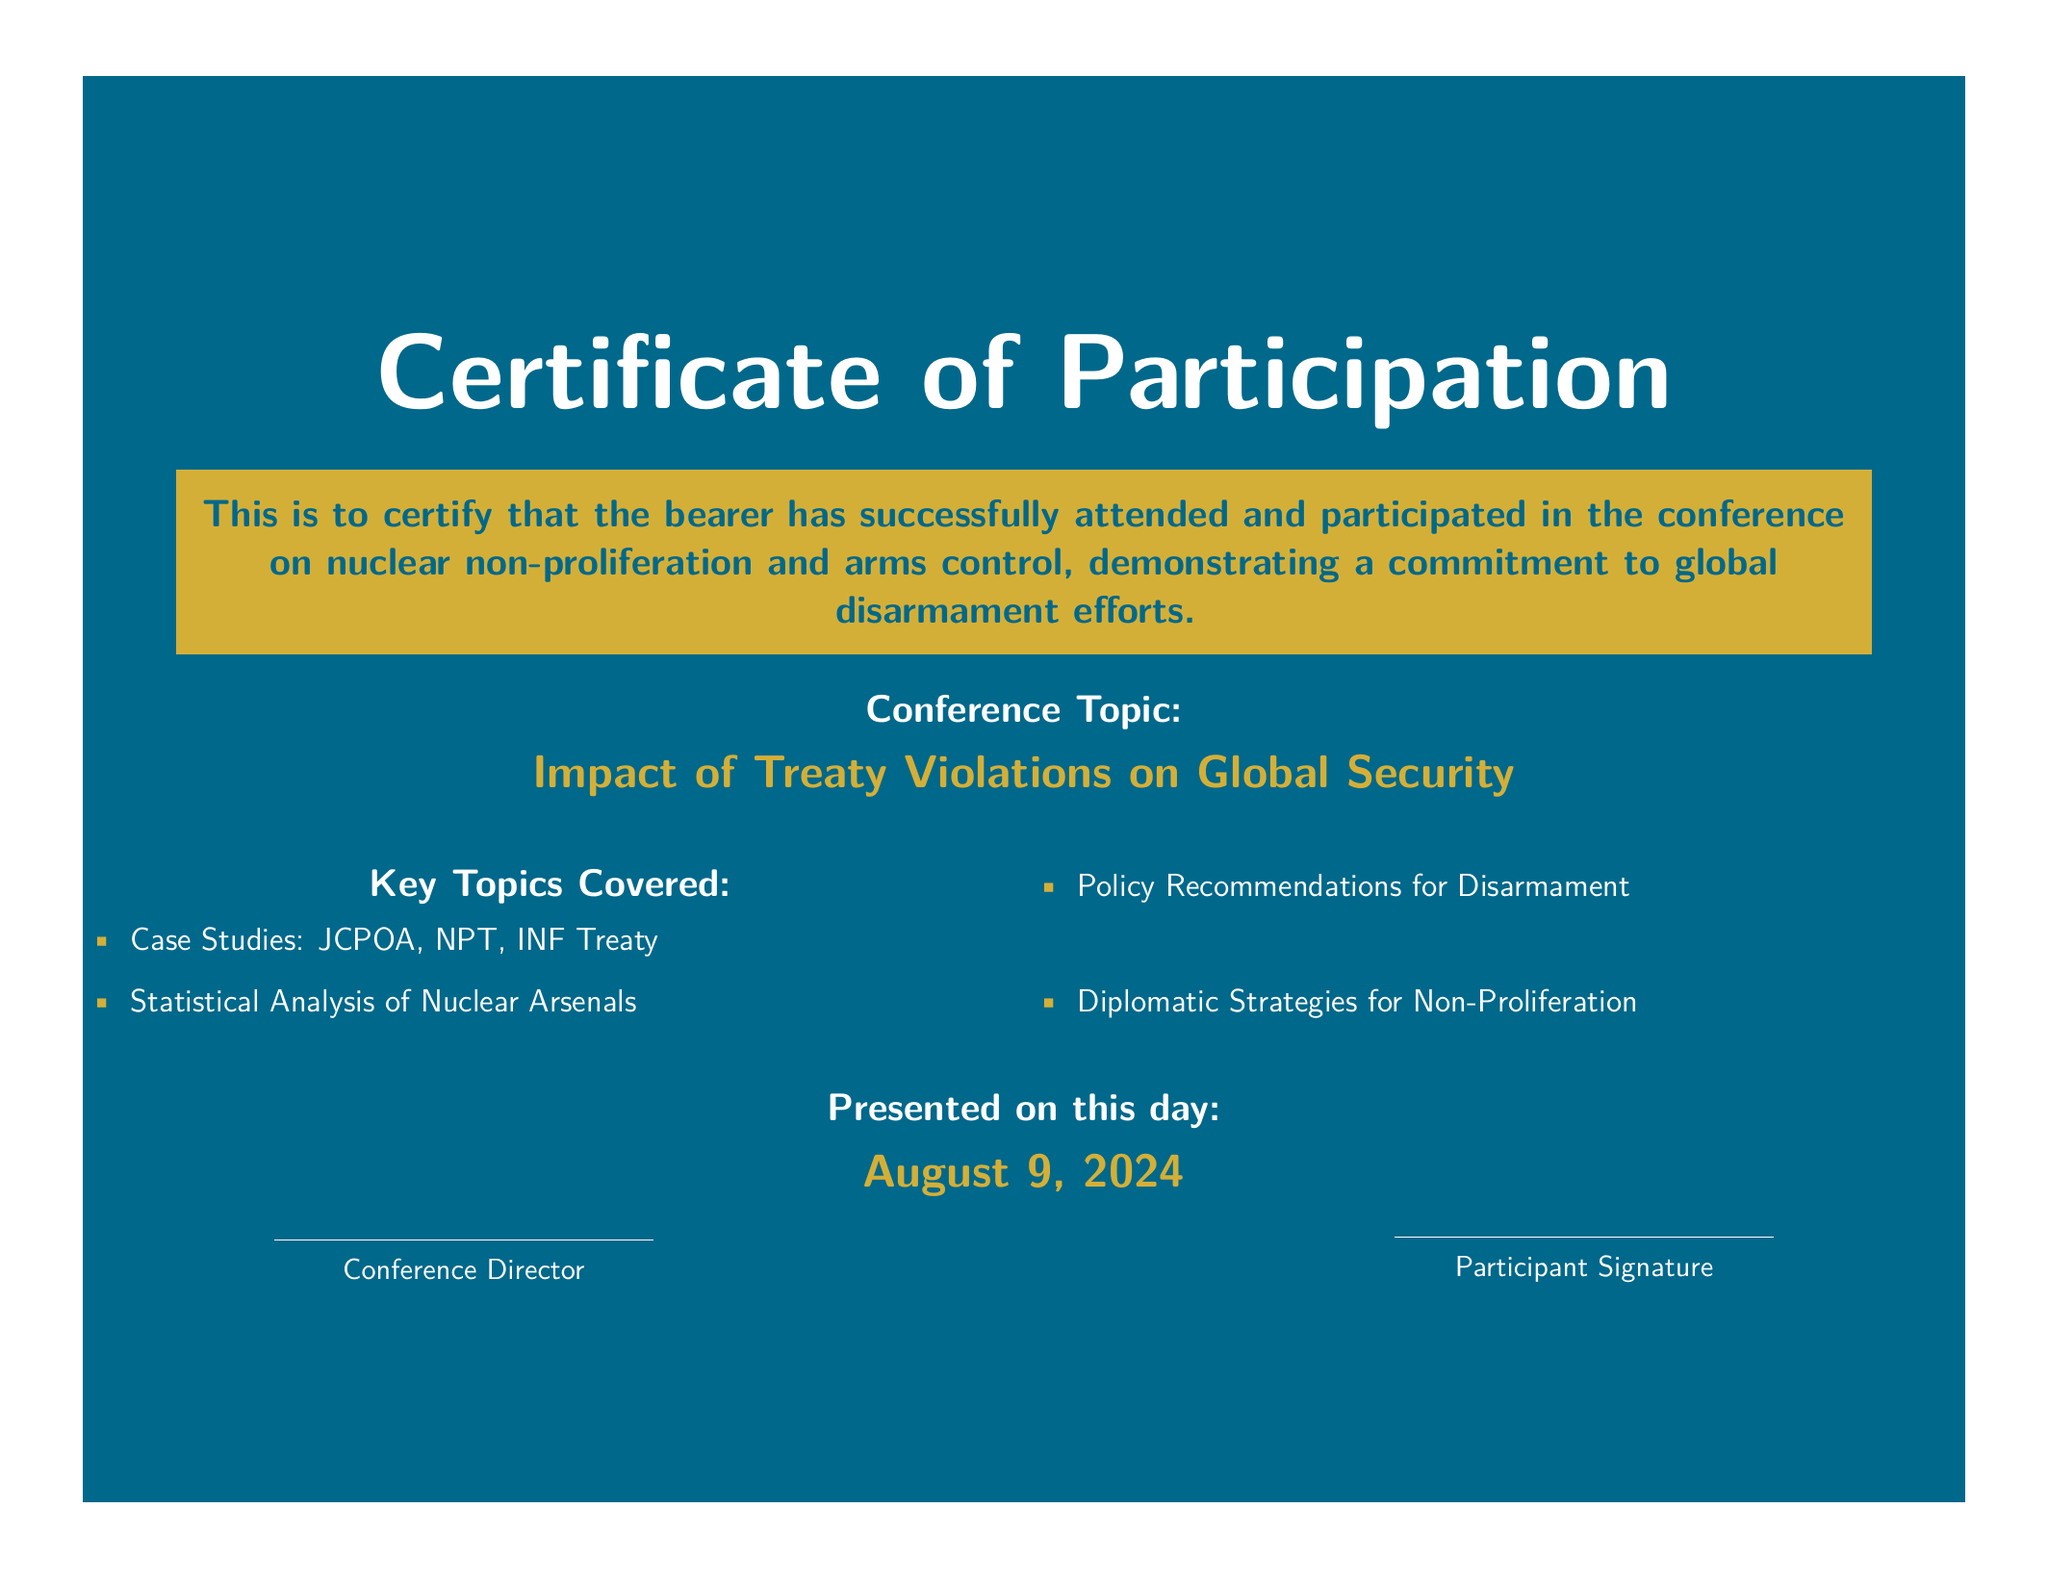What is the name of the document? The document is titled "Certificate of Participation."
Answer: Certificate of Participation What is the topic of the conference? The topic highlighted in the document is about the focus of the conference.
Answer: Impact of Treaty Violations on Global Security Who presented the diploma? The diploma states that it was presented by the conference director.
Answer: Conference Director What are the key topics covered? Key topics are listed in a bulleted format in the document.
Answer: Case Studies: JCPOA, NPT, INF Treaty What is the significance of the conference for the participant? The document indicates the purpose of attending the conference.
Answer: Commitment to global disarmament efforts On what date was the conference conducted? The date of the conference is indicated directly on the document.
Answer: Today's date 